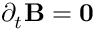<formula> <loc_0><loc_0><loc_500><loc_500>\partial _ { t } B = 0</formula> 